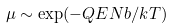<formula> <loc_0><loc_0><loc_500><loc_500>\mu \sim \exp ( - Q E N b / k T )</formula> 